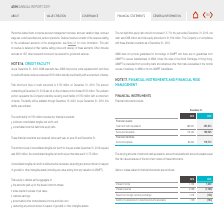According to Asm International Nv's financial document, Why is the carrying amounts of the segments of financial instrustments equal to their fair values? because of the short-term nature of these instruments. The document states: "their fair values because of the short-term nature of these instruments...." Also, What is the Accounts receivable for 2018? According to the financial document, 173,450. The relevant text states: "Accounts receivable 173,450 199,535..." Also, What is the Accounts payable for 2019? According to the financial document, 119,712. The relevant text states: "Accounts payable 80,640 119,712..." Also, can you calculate: What is the financial equity in 2018? Based on the calculation: 285,907+173,450-80,640, the result is 378717. This is based on the information: "Accounts receivable 173,450 199,535 Cash and cash equivalents 285,907 497,874 Accounts payable 80,640 119,712..." The key data points involved are: 173,450, 285,907, 80,640. Also, can you calculate: What is the change in accounts payable from 2018 to 2019? Based on the calculation: 119,712- 80,640 , the result is 39072. This is based on the information: "Accounts payable 80,640 119,712 Accounts payable 80,640 119,712..." The key data points involved are: 119,712, 80,640. Additionally, Which year has the higher total financial assets? According to the financial document, 2019. The relevant text states: "2018 2019..." 